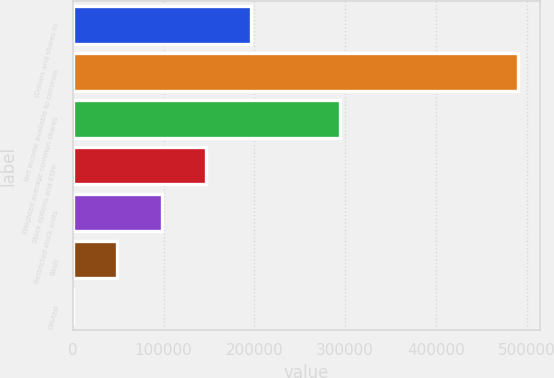Convert chart. <chart><loc_0><loc_0><loc_500><loc_500><bar_chart><fcel>(Dollars and shares in<fcel>Net income available to common<fcel>Weighted average common shares<fcel>Stock options and ESPP<fcel>Restricted stock units<fcel>Basic<fcel>Diluted<nl><fcel>196208<fcel>490506<fcel>294307<fcel>147158<fcel>98108.6<fcel>49058.9<fcel>9.2<nl></chart> 